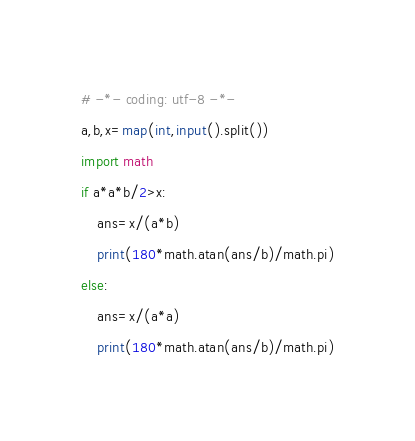<code> <loc_0><loc_0><loc_500><loc_500><_Python_># -*- coding: utf-8 -*-
a,b,x=map(int,input().split())
import math
if a*a*b/2>x:
    ans=x/(a*b)
    print(180*math.atan(ans/b)/math.pi)
else:
    ans=x/(a*a)
    print(180*math.atan(ans/b)/math.pi)</code> 